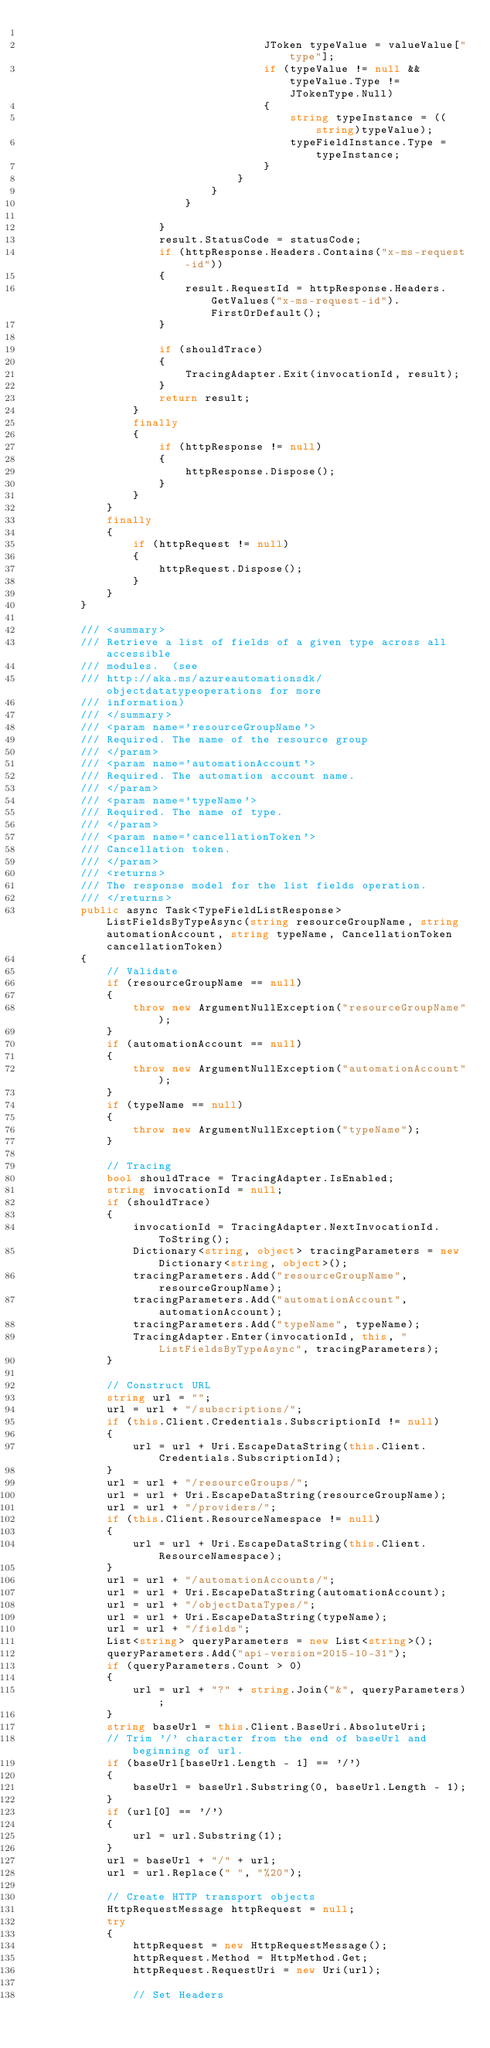<code> <loc_0><loc_0><loc_500><loc_500><_C#_>                                    
                                    JToken typeValue = valueValue["type"];
                                    if (typeValue != null && typeValue.Type != JTokenType.Null)
                                    {
                                        string typeInstance = ((string)typeValue);
                                        typeFieldInstance.Type = typeInstance;
                                    }
                                }
                            }
                        }
                        
                    }
                    result.StatusCode = statusCode;
                    if (httpResponse.Headers.Contains("x-ms-request-id"))
                    {
                        result.RequestId = httpResponse.Headers.GetValues("x-ms-request-id").FirstOrDefault();
                    }
                    
                    if (shouldTrace)
                    {
                        TracingAdapter.Exit(invocationId, result);
                    }
                    return result;
                }
                finally
                {
                    if (httpResponse != null)
                    {
                        httpResponse.Dispose();
                    }
                }
            }
            finally
            {
                if (httpRequest != null)
                {
                    httpRequest.Dispose();
                }
            }
        }
        
        /// <summary>
        /// Retrieve a list of fields of a given type across all accessible
        /// modules.  (see
        /// http://aka.ms/azureautomationsdk/objectdatatypeoperations for more
        /// information)
        /// </summary>
        /// <param name='resourceGroupName'>
        /// Required. The name of the resource group
        /// </param>
        /// <param name='automationAccount'>
        /// Required. The automation account name.
        /// </param>
        /// <param name='typeName'>
        /// Required. The name of type.
        /// </param>
        /// <param name='cancellationToken'>
        /// Cancellation token.
        /// </param>
        /// <returns>
        /// The response model for the list fields operation.
        /// </returns>
        public async Task<TypeFieldListResponse> ListFieldsByTypeAsync(string resourceGroupName, string automationAccount, string typeName, CancellationToken cancellationToken)
        {
            // Validate
            if (resourceGroupName == null)
            {
                throw new ArgumentNullException("resourceGroupName");
            }
            if (automationAccount == null)
            {
                throw new ArgumentNullException("automationAccount");
            }
            if (typeName == null)
            {
                throw new ArgumentNullException("typeName");
            }
            
            // Tracing
            bool shouldTrace = TracingAdapter.IsEnabled;
            string invocationId = null;
            if (shouldTrace)
            {
                invocationId = TracingAdapter.NextInvocationId.ToString();
                Dictionary<string, object> tracingParameters = new Dictionary<string, object>();
                tracingParameters.Add("resourceGroupName", resourceGroupName);
                tracingParameters.Add("automationAccount", automationAccount);
                tracingParameters.Add("typeName", typeName);
                TracingAdapter.Enter(invocationId, this, "ListFieldsByTypeAsync", tracingParameters);
            }
            
            // Construct URL
            string url = "";
            url = url + "/subscriptions/";
            if (this.Client.Credentials.SubscriptionId != null)
            {
                url = url + Uri.EscapeDataString(this.Client.Credentials.SubscriptionId);
            }
            url = url + "/resourceGroups/";
            url = url + Uri.EscapeDataString(resourceGroupName);
            url = url + "/providers/";
            if (this.Client.ResourceNamespace != null)
            {
                url = url + Uri.EscapeDataString(this.Client.ResourceNamespace);
            }
            url = url + "/automationAccounts/";
            url = url + Uri.EscapeDataString(automationAccount);
            url = url + "/objectDataTypes/";
            url = url + Uri.EscapeDataString(typeName);
            url = url + "/fields";
            List<string> queryParameters = new List<string>();
            queryParameters.Add("api-version=2015-10-31");
            if (queryParameters.Count > 0)
            {
                url = url + "?" + string.Join("&", queryParameters);
            }
            string baseUrl = this.Client.BaseUri.AbsoluteUri;
            // Trim '/' character from the end of baseUrl and beginning of url.
            if (baseUrl[baseUrl.Length - 1] == '/')
            {
                baseUrl = baseUrl.Substring(0, baseUrl.Length - 1);
            }
            if (url[0] == '/')
            {
                url = url.Substring(1);
            }
            url = baseUrl + "/" + url;
            url = url.Replace(" ", "%20");
            
            // Create HTTP transport objects
            HttpRequestMessage httpRequest = null;
            try
            {
                httpRequest = new HttpRequestMessage();
                httpRequest.Method = HttpMethod.Get;
                httpRequest.RequestUri = new Uri(url);
                
                // Set Headers</code> 